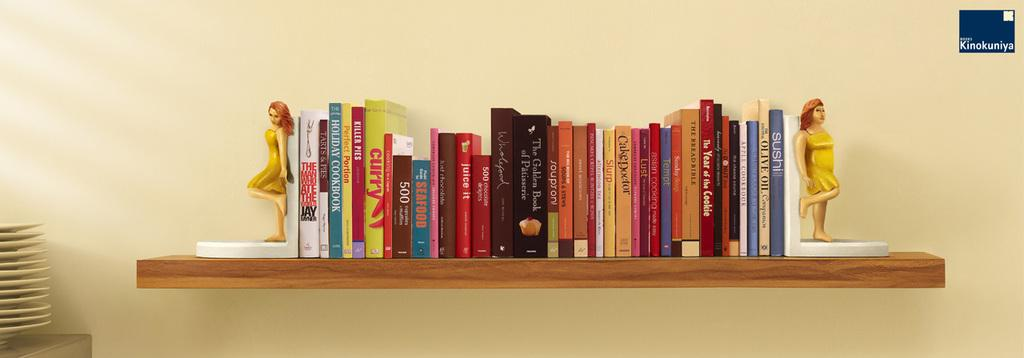<image>
Share a concise interpretation of the image provided. Various books on the bookshelf and one of them is Seafood 